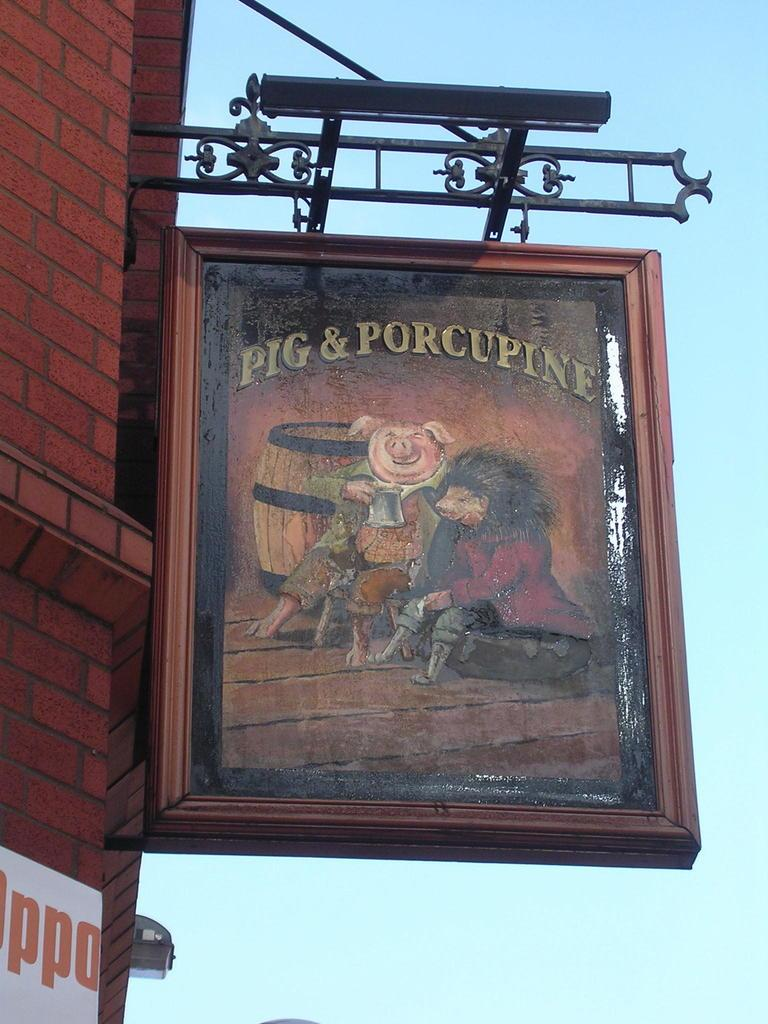<image>
Present a compact description of the photo's key features. Sign on a building that says Pig & Porcupine. 